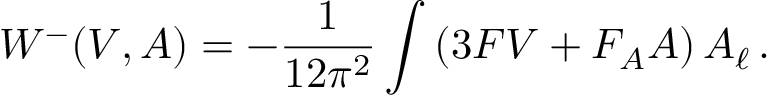<formula> <loc_0><loc_0><loc_500><loc_500>W ^ { - } ( V , A ) = - \frac { 1 } { 1 2 \pi ^ { 2 } } \int \left ( 3 F V + F _ { A } A \right ) A _ { \ell } \, .</formula> 